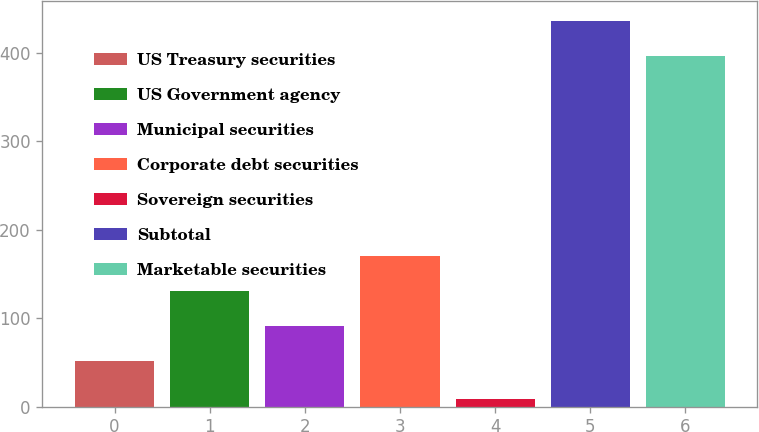Convert chart. <chart><loc_0><loc_0><loc_500><loc_500><bar_chart><fcel>US Treasury securities<fcel>US Government agency<fcel>Municipal securities<fcel>Corporate debt securities<fcel>Sovereign securities<fcel>Subtotal<fcel>Marketable securities<nl><fcel>52<fcel>131.2<fcel>91.6<fcel>170.8<fcel>9<fcel>436.6<fcel>397<nl></chart> 